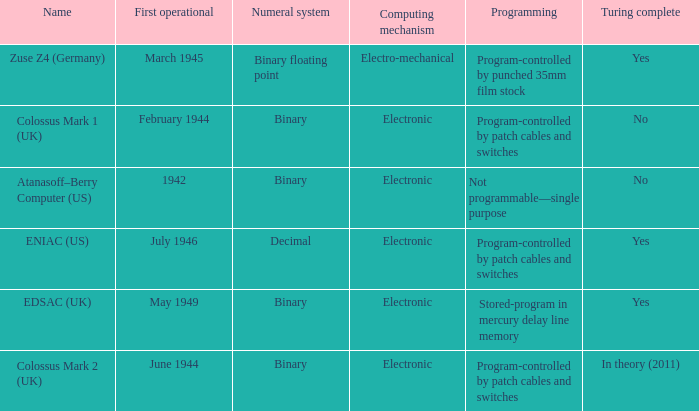What is the computing mechanism called atanasoff-berry computer (us)? Electronic. 